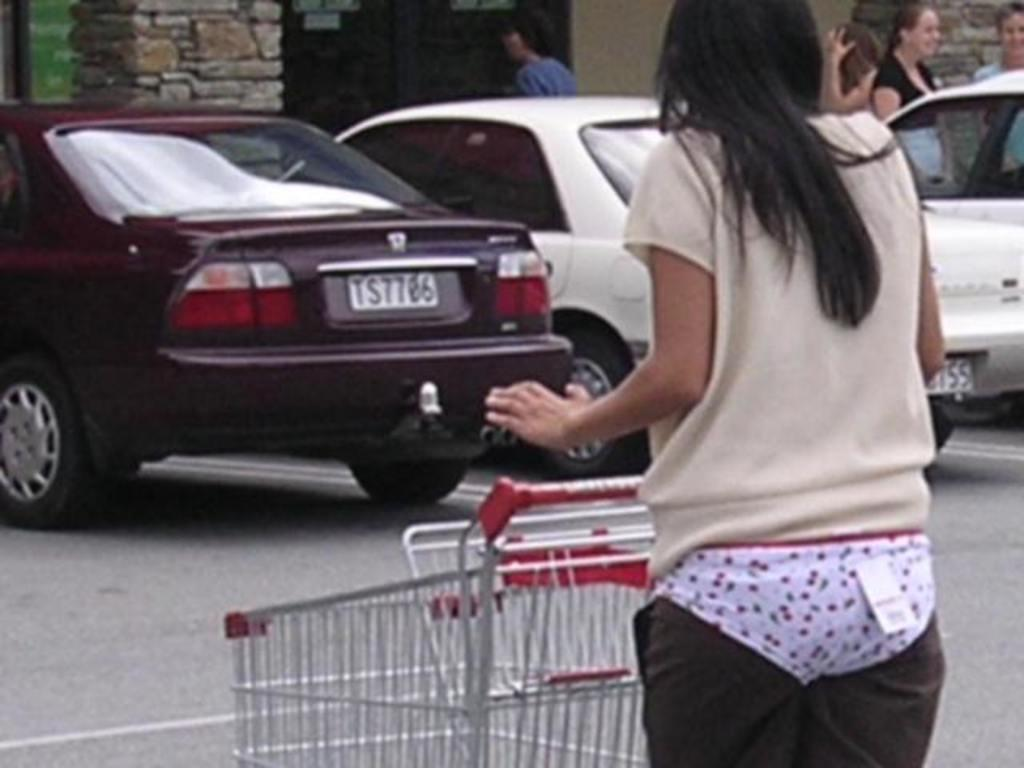What is the person in the image holding? The person is holding a trolley in the image. What can be seen in the background of the image? There are vehicles on the road, people, a building, and a glass window in the background. What might the person be doing with the trolley? The person might be using the trolley to carry items or belongings. Can you describe the setting of the image? The image is set in an area with vehicles, people, and a building in the background. What type of sweater is the person wearing in the image? The image does not show the person wearing a sweater, so it cannot be determined from the image. 